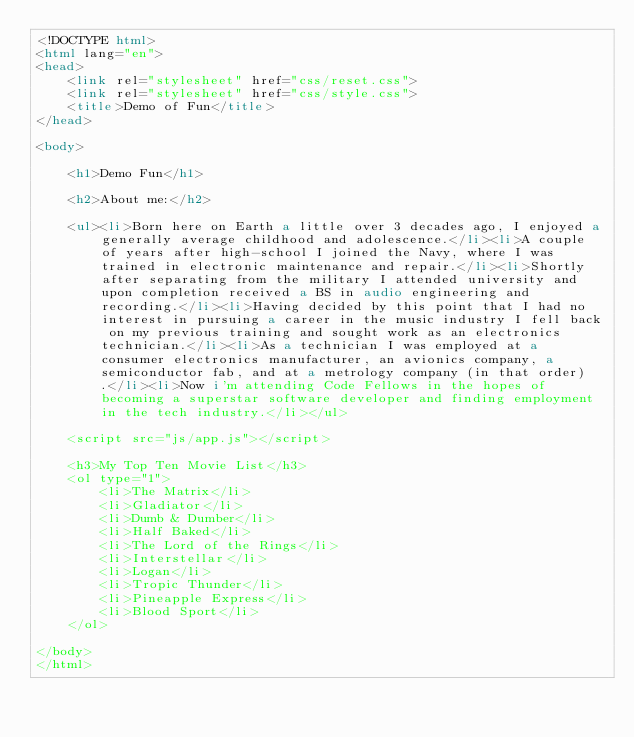<code> <loc_0><loc_0><loc_500><loc_500><_HTML_><!DOCTYPE html>
<html lang="en">
<head>
    <link rel="stylesheet" href="css/reset.css">
    <link rel="stylesheet" href="css/style.css">
    <title>Demo of Fun</title>
</head>

<body>
    
    <h1>Demo Fun</h1>

    <h2>About me:</h2>

    <ul><li>Born here on Earth a little over 3 decades ago, I enjoyed a generally average childhood and adolescence.</li><li>A couple of years after high-school I joined the Navy, where I was trained in electronic maintenance and repair.</li><li>Shortly after separating from the military I attended university and upon completion received a BS in audio engineering and recording.</li><li>Having decided by this point that I had no interest in pursuing a career in the music industry I fell back on my previous training and sought work as an electronics technician.</li><li>As a technician I was employed at a consumer electronics manufacturer, an avionics company, a semiconductor fab, and at a metrology company (in that order).</li><li>Now i'm attending Code Fellows in the hopes of becoming a superstar software developer and finding employment in the tech industry.</li></ul>

    <script src="js/app.js"></script>

    <h3>My Top Ten Movie List</h3>
    <ol type="1">
        <li>The Matrix</li>
        <li>Gladiator</li>
        <li>Dumb & Dumber</li>
        <li>Half Baked</li>
        <li>The Lord of the Rings</li>
        <li>Interstellar</li>
        <li>Logan</li>
        <li>Tropic Thunder</li>
        <li>Pineapple Express</li>
        <li>Blood Sport</li>
    </ol>
    
</body>
</html></code> 